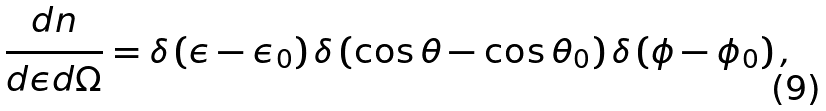<formula> <loc_0><loc_0><loc_500><loc_500>\frac { d n } { d \epsilon d \Omega } = \delta \left ( \epsilon - \epsilon _ { 0 } \right ) \delta \left ( \cos \theta - \cos \theta _ { 0 } \right ) \delta \left ( \phi - \phi _ { 0 } \right ) ,</formula> 